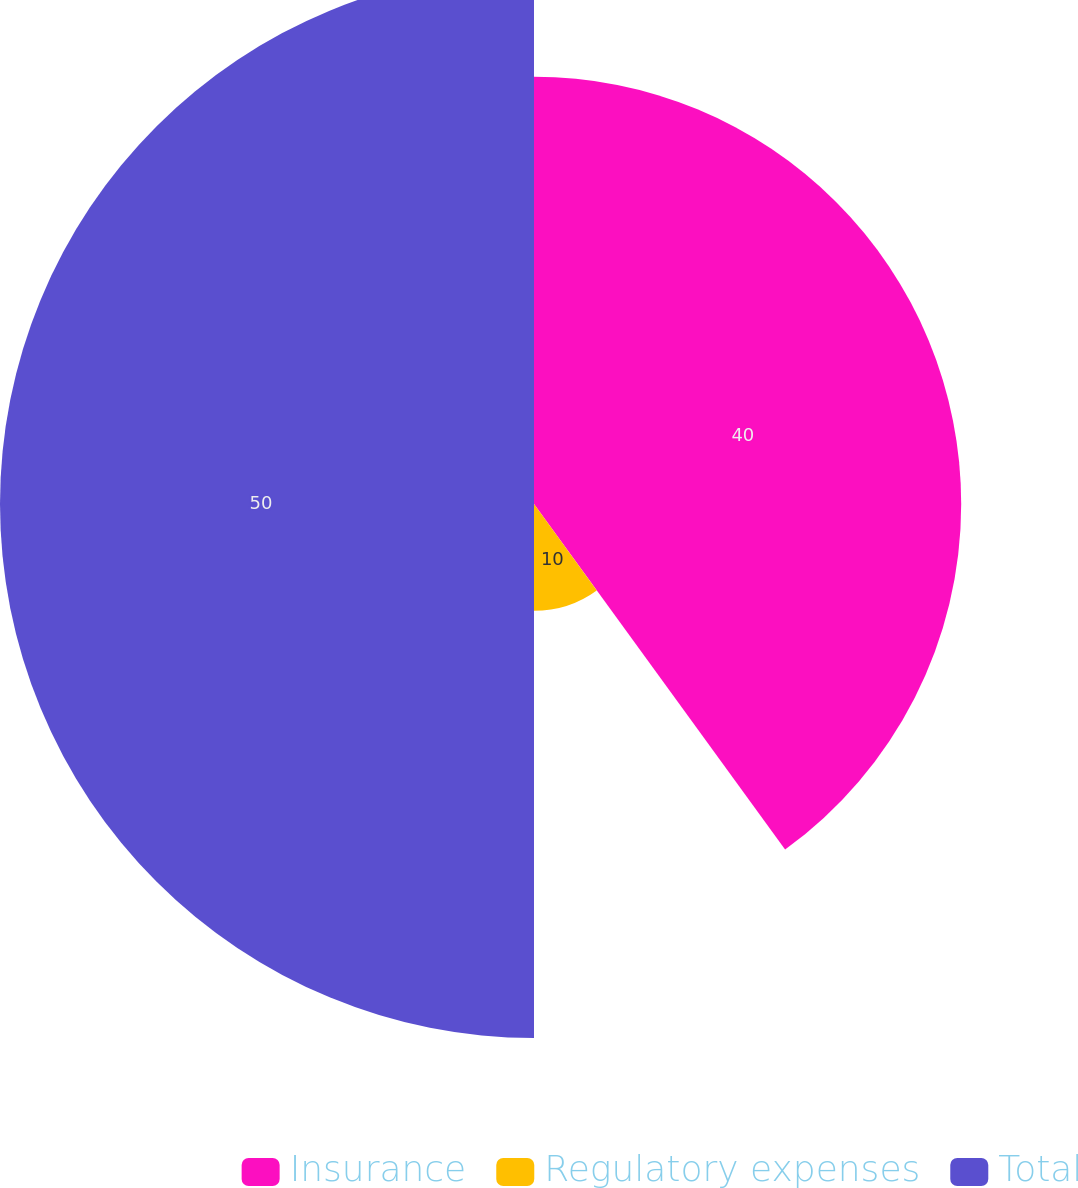Convert chart. <chart><loc_0><loc_0><loc_500><loc_500><pie_chart><fcel>Insurance<fcel>Regulatory expenses<fcel>Total<nl><fcel>40.0%<fcel>10.0%<fcel>50.0%<nl></chart> 